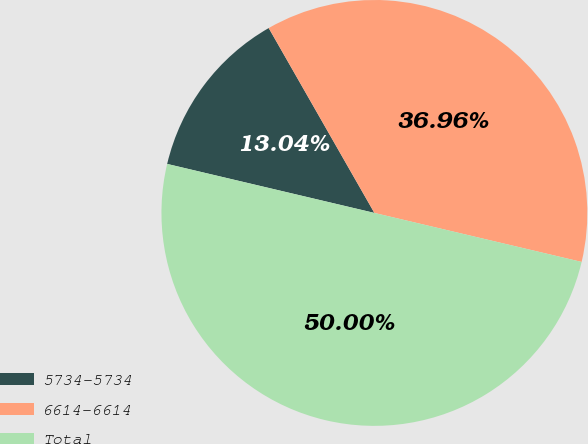Convert chart to OTSL. <chart><loc_0><loc_0><loc_500><loc_500><pie_chart><fcel>5734-5734<fcel>6614-6614<fcel>Total<nl><fcel>13.04%<fcel>36.96%<fcel>50.0%<nl></chart> 